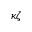Convert formula to latex. <formula><loc_0><loc_0><loc_500><loc_500>\kappa \zeta</formula> 